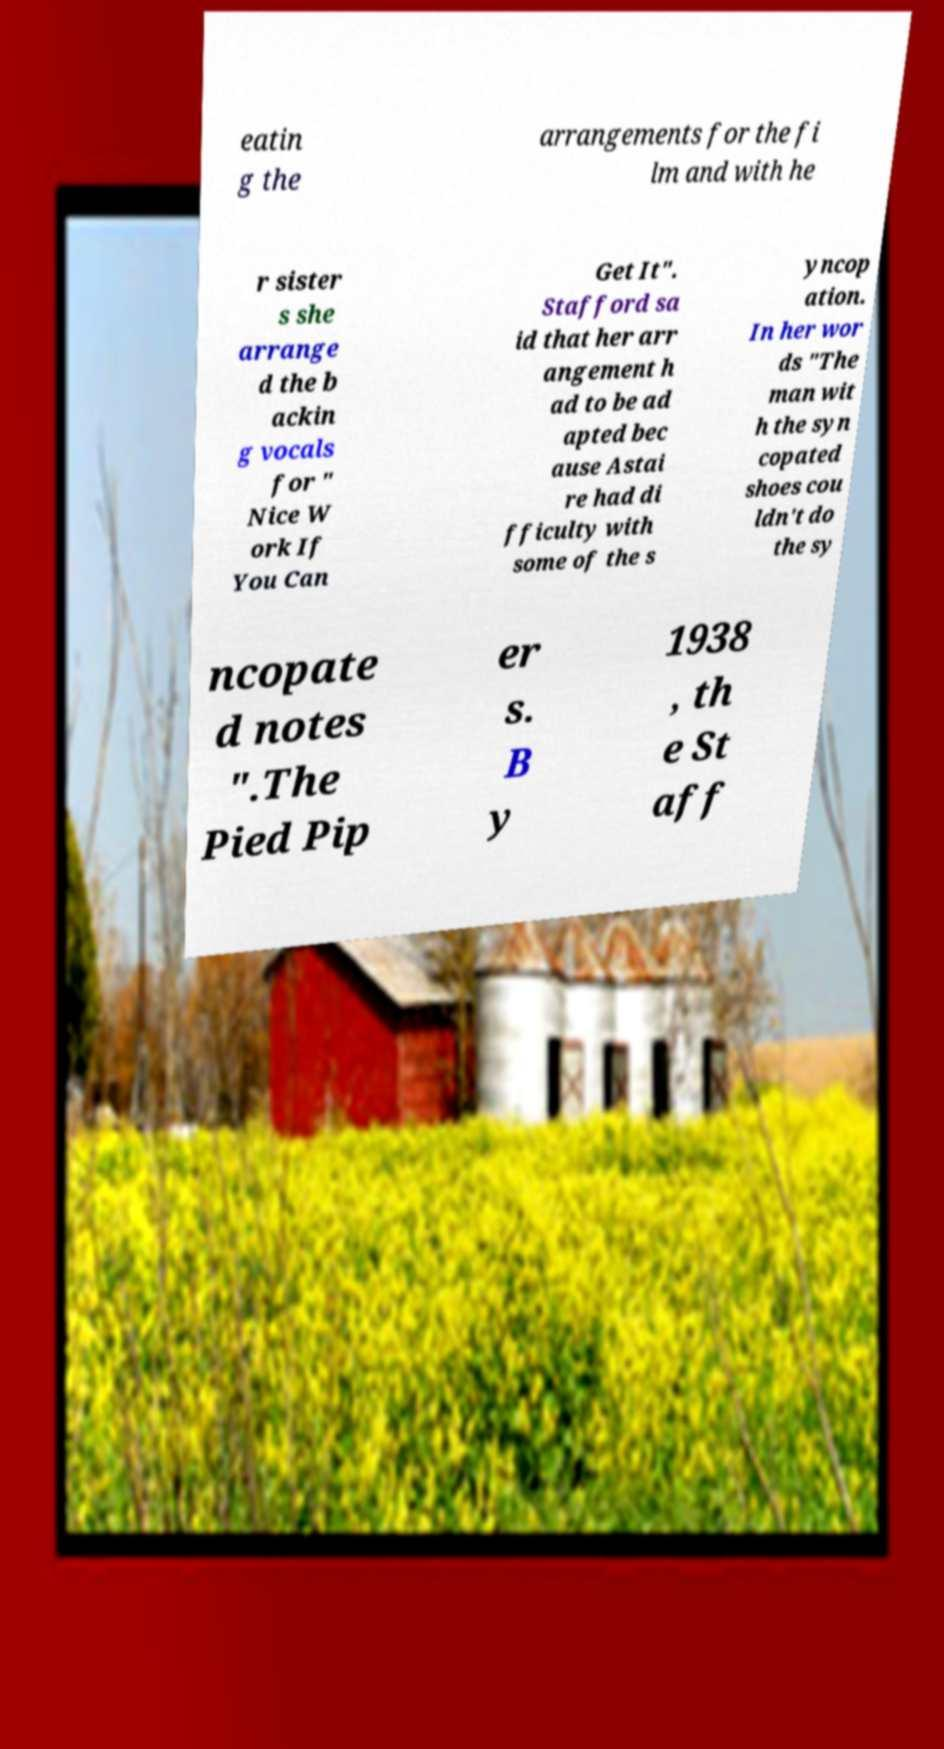Could you assist in decoding the text presented in this image and type it out clearly? eatin g the arrangements for the fi lm and with he r sister s she arrange d the b ackin g vocals for " Nice W ork If You Can Get It". Stafford sa id that her arr angement h ad to be ad apted bec ause Astai re had di fficulty with some of the s yncop ation. In her wor ds "The man wit h the syn copated shoes cou ldn't do the sy ncopate d notes ".The Pied Pip er s. B y 1938 , th e St aff 